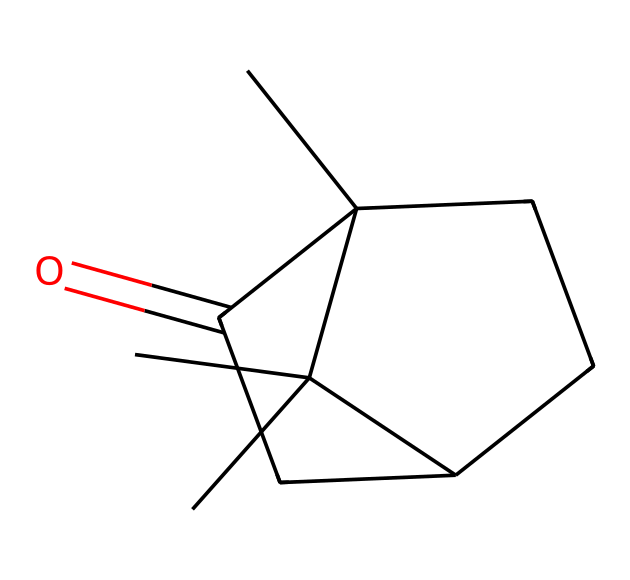What is the functional group present in camphor? The molecule features a carbonyl group (C=O) which is characteristic of ketones. This can be identified in the structure where there is a carbon atom double-bonded to an oxygen atom.
Answer: carbonyl How many carbon atoms are in the molecular structure of camphor? By analyzing the SMILES representation, I can count the number of carbon atoms represented. The structure has 10 carbon atoms overall in the cyclic and branching components.
Answer: 10 What is the total number of hydrogen atoms in camphor? In the molecular structure, each carbon atom typically can bond with two hydrogens unless they are bonded with other elements such as oxygen or are part of a double bond. After counting, there are 16 hydrogen atoms associated with the 10 carbons producing a stable structure.
Answer: 16 Is camphor a saturated or unsaturated compound? The presence of double bonds in the carbonyl functional group and in the cyclic structure indicates that it is unsaturated, as saturated compounds have single bonds only.
Answer: unsaturated What type of chemical compound is camphor? Based on the functional group and the overall structure, which includes the ketone group, camphor is classified as a ketone or more specifically a bicyclic ketone due to its unique ring structure.
Answer: ketone 